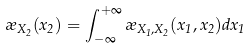<formula> <loc_0><loc_0><loc_500><loc_500>\rho _ { X _ { 2 } } ( x _ { 2 } ) = \int _ { - \infty } ^ { + \infty } \rho _ { X _ { 1 } , X _ { 2 } } ( x _ { 1 } , x _ { 2 } ) d x _ { 1 }</formula> 